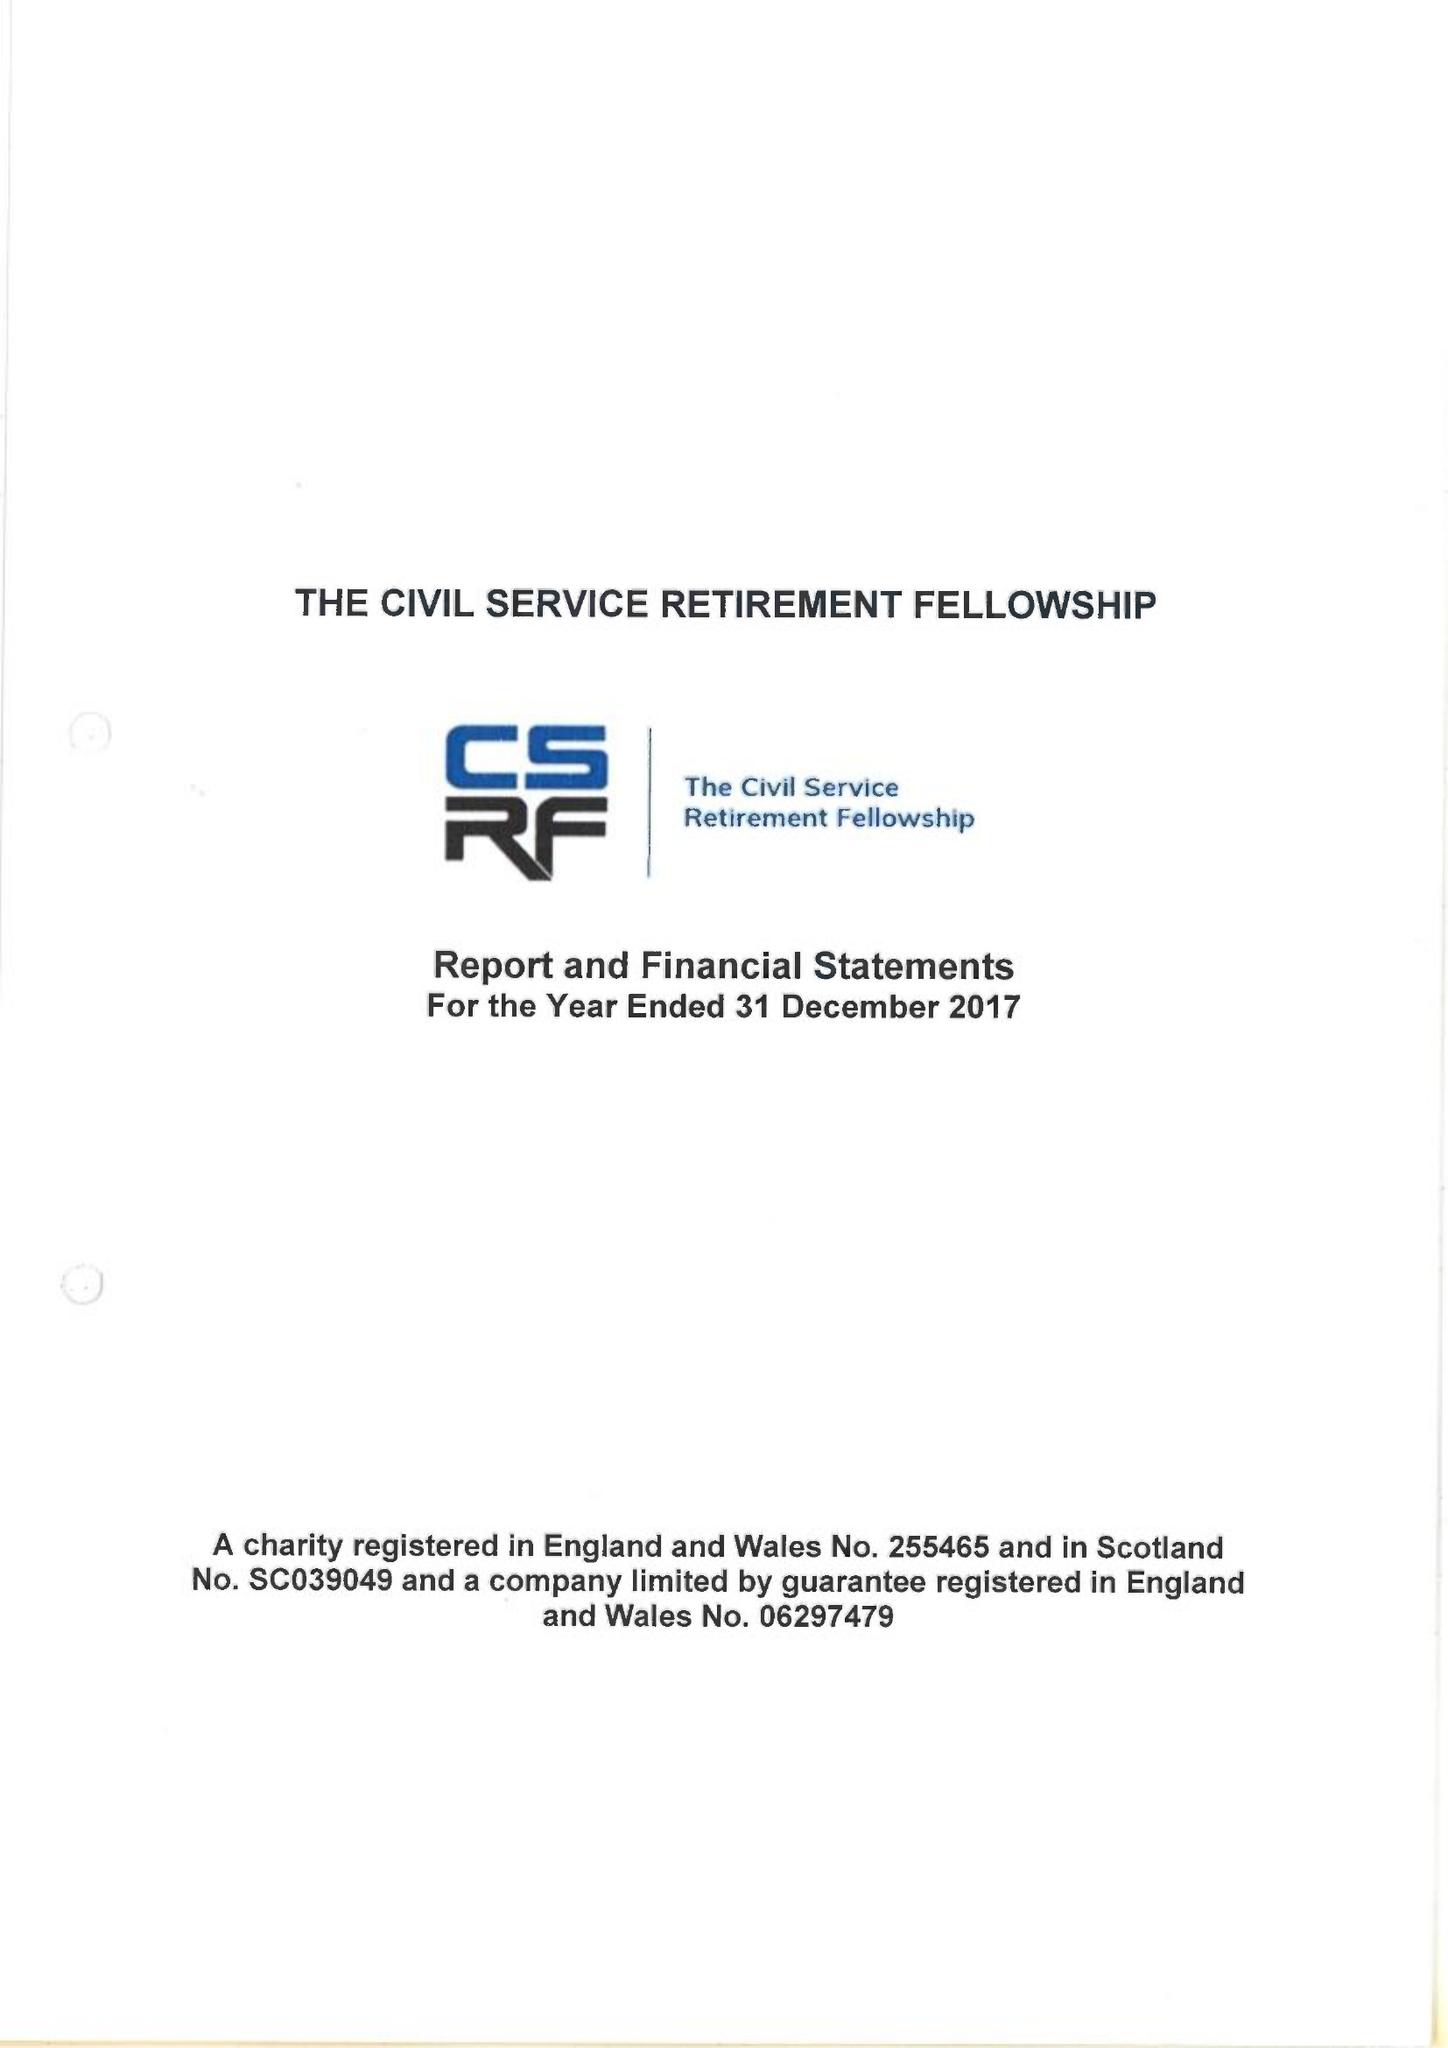What is the value for the address__postcode?
Answer the question using a single word or phrase. SE8 3EY 